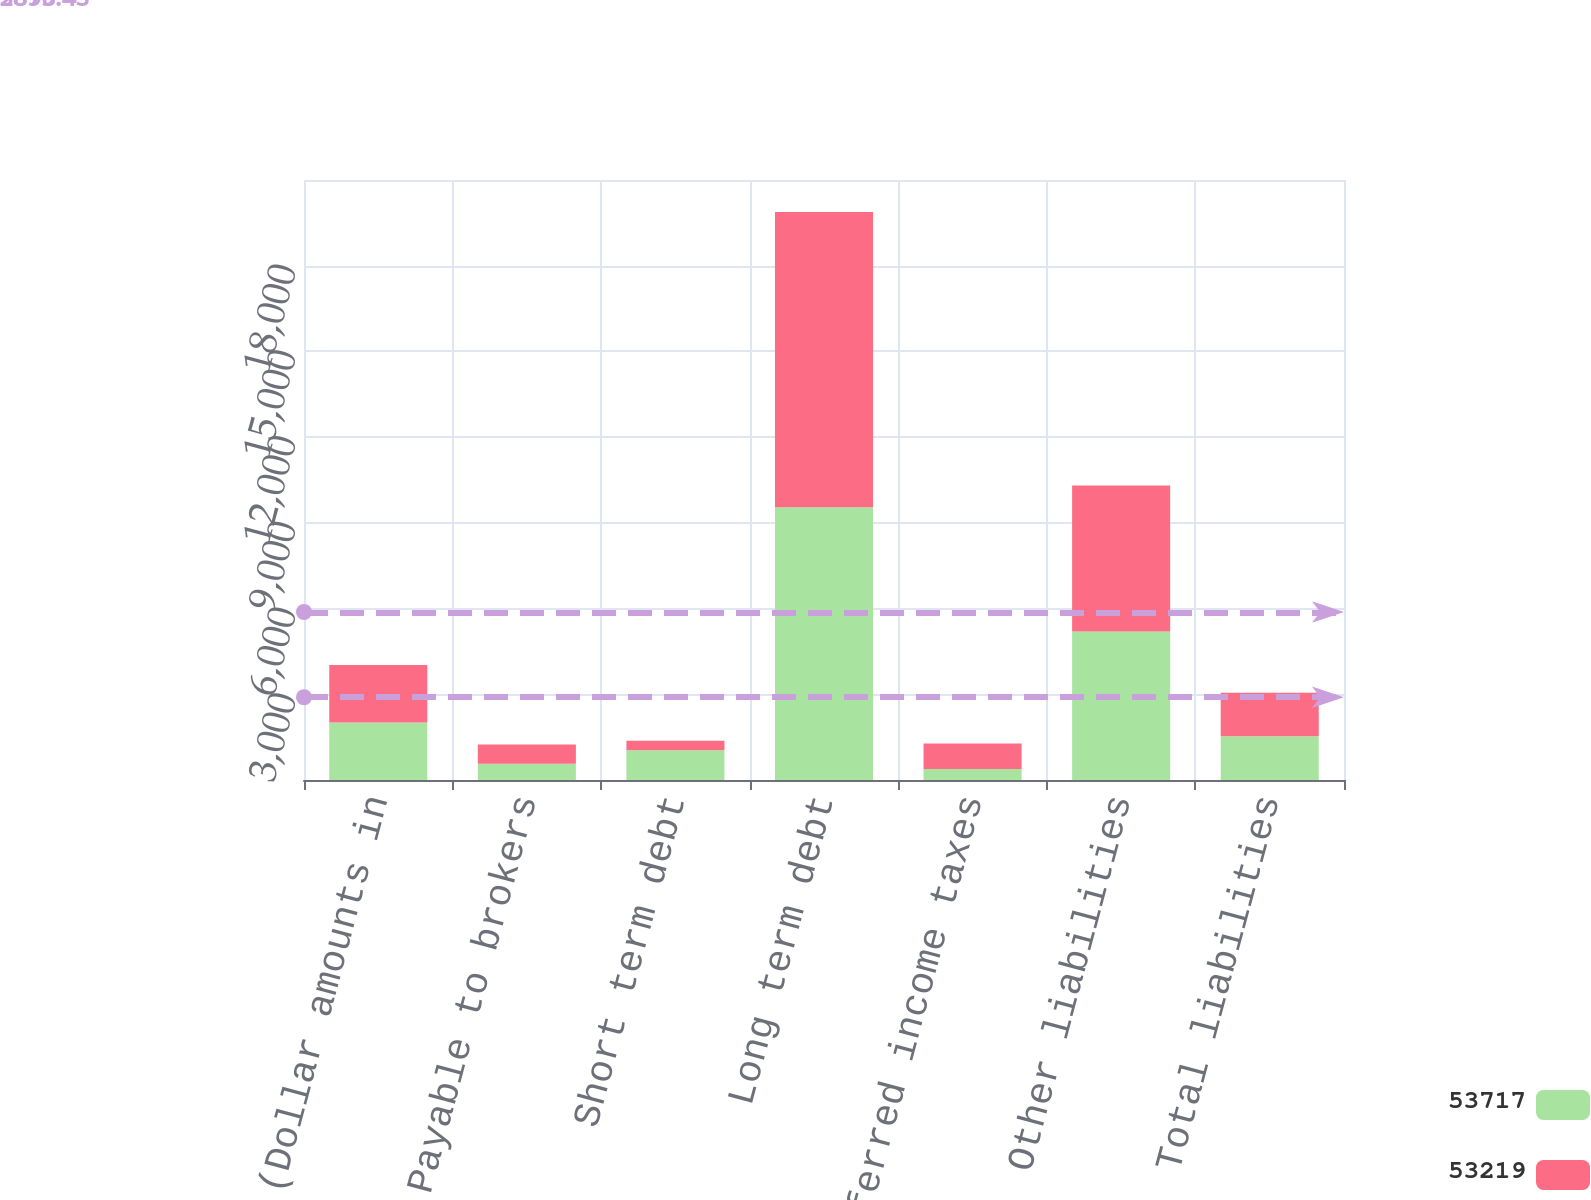Convert chart to OTSL. <chart><loc_0><loc_0><loc_500><loc_500><stacked_bar_chart><ecel><fcel>December 31 (Dollar amounts in<fcel>Payable to brokers<fcel>Short term debt<fcel>Long term debt<fcel>Deferred income taxes<fcel>Other liabilities<fcel>Total liabilities<nl><fcel>53717<fcel>2015<fcel>567<fcel>1040<fcel>9543<fcel>382<fcel>5201<fcel>1527<nl><fcel>53219<fcel>2014<fcel>673<fcel>335<fcel>10333<fcel>893<fcel>5103<fcel>1527<nl></chart> 